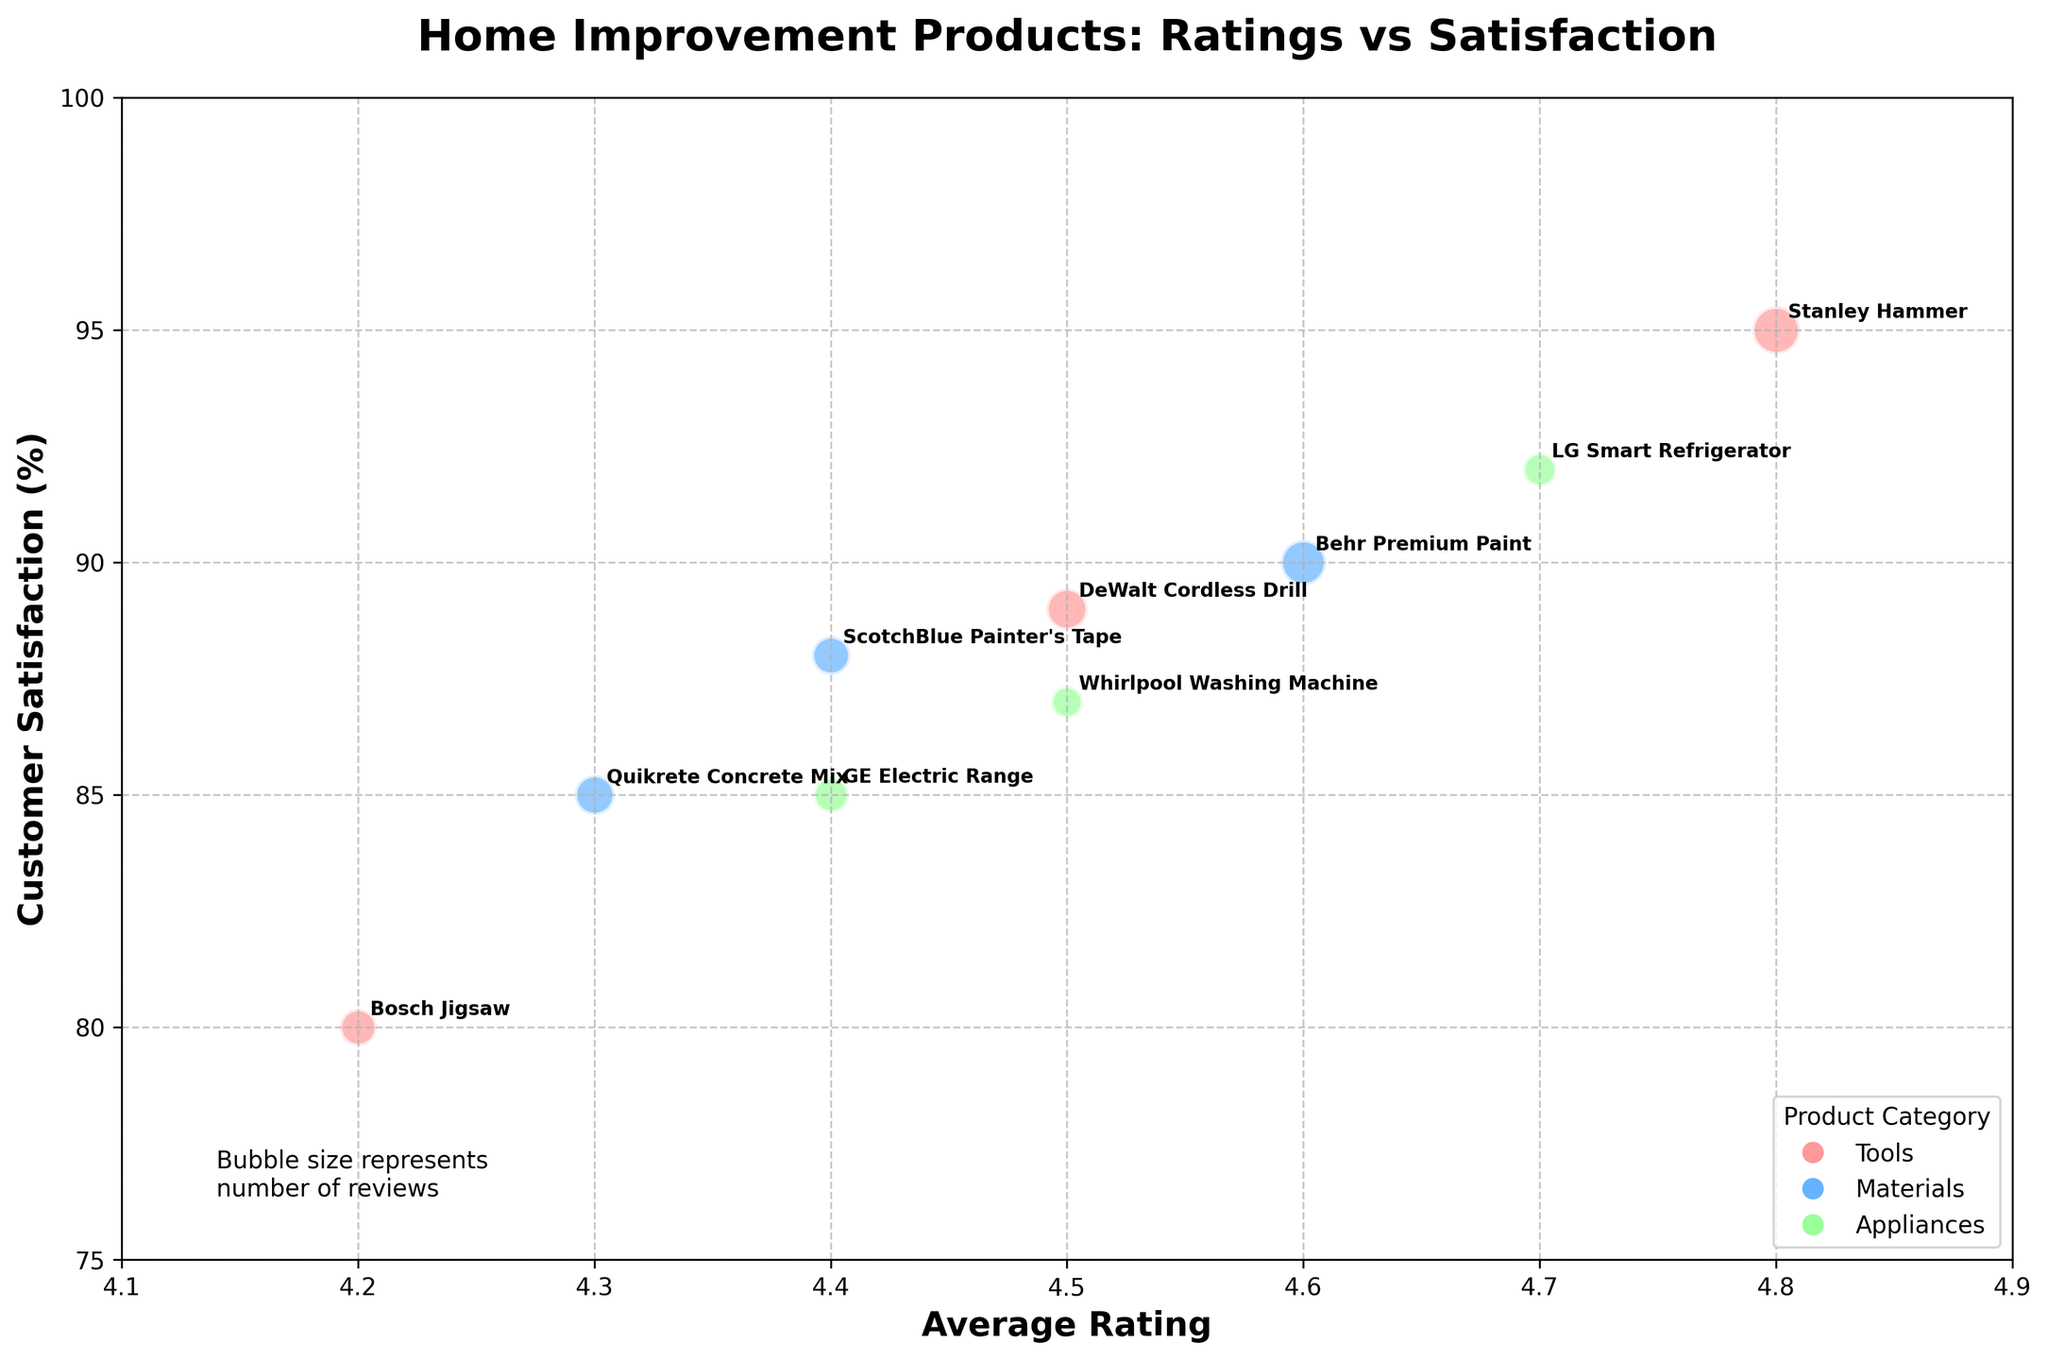How many different product categories are shown in the plot? The plot contains bubbles in three different colors, each representing a different product category. The colors correspond to Tools, Materials, and Appliances as shown in the legend.
Answer: Three Which product has the highest customer satisfaction? The highest point on the y-axis, which represents customer satisfaction, is achieved by the Stanley Hammer. Both the data point position and the annotation indicate this.
Answer: Stanley Hammer What is the average rating of the LG Smart Refrigerator? The LG Smart Refrigerator is labeled in the Appliances category. Its position on the x-axis, which reflects the average rating, is at 4.7.
Answer: 4.7 How many reviews does the DeWalt Cordless Drill have? Each bubble size represents the number of reviews, and the DeWalt Cordless Drill is annotated. Checking the bubble's size compared to others in its category, we find the number of reviews is 150.
Answer: 150 Which tool has a higher customer satisfaction: the Bosch Jigsaw or the DeWalt Cordless Drill? The bubbles representing the Bosch Jigsaw and the DeWalt Cordless Drill are found within the tools category. The DeWalt Cordless Drill is higher on the y-axis (89) compared to the Bosch Jigsaw (80), meaning it has higher customer satisfaction.
Answer: DeWalt Cordless Drill Compare the average ratings of Behr Premium Paint and Quikrete Concrete Mix. Which one is higher? Both products are in the materials category. The average rating of Behr Premium Paint is 4.6, while Quikrete Concrete Mix has an average rating of 4.3. Behr Premium Paint has a higher average rating.
Answer: Behr Premium Paint What is the relationship between the number of reviews and customer satisfaction for the Products in the Tools category? The Tools category includes DeWalt Cordless Drill, Bosch Jigsaw, and Stanley Hammer. Larger bubbles indicate more reviews. Although the sizes vary, higher customer satisfaction does not consistently align with more reviews. The Stanley Hammer has the highest satisfaction and also most reviews, while Bosch Jigsaw has lower satisfaction and reviews, and DeWalt is in the middle.
Answer: No consistent relationship Which appliance has the lowest average rating? The appliances category includes the LG Smart Refrigerator, Whirlpool Washing Machine, and GE Electric Range. The lowest x-axis position among these is the GE Electric Range at 4.4.
Answer: GE Electric Range What is the difference in customer satisfaction between ScotchBlue Painter's Tape and GE Electric Range? Found in the Materials and Appliances categories, respectively, ScotchBlue Painter's Tape has a satisfaction level of 88, and GE Electric Range shows 85. The difference between them is calculated as 88 - 85.
Answer: 3 How many products have an average rating above 4.5? By examining the x-axis and noting products situated to the right of 4.5, the following products qualify: DeWalt Cordless Drill, Stanley Hammer, Behr Premium Paint, and LG Smart Refrigerator, totaling four products.
Answer: Four 